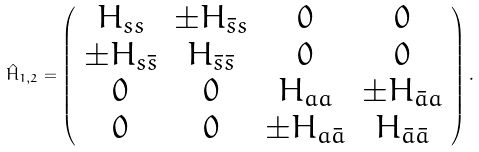<formula> <loc_0><loc_0><loc_500><loc_500>\hat { H } _ { 1 , 2 } = \left ( \begin{array} { c c c c } H _ { s s } & \pm H _ { { \bar { s } } s } & 0 & 0 \\ \pm H _ { s { \bar { s } } } & H _ { { \bar { s } } { \bar { s } } } & 0 & 0 \\ 0 & 0 & H _ { a a } & \pm H _ { { \bar { a } } a } \\ 0 & 0 & \pm H _ { a { \bar { a } } } & H _ { { \bar { a } } { \bar { a } } } \end{array} \right ) .</formula> 